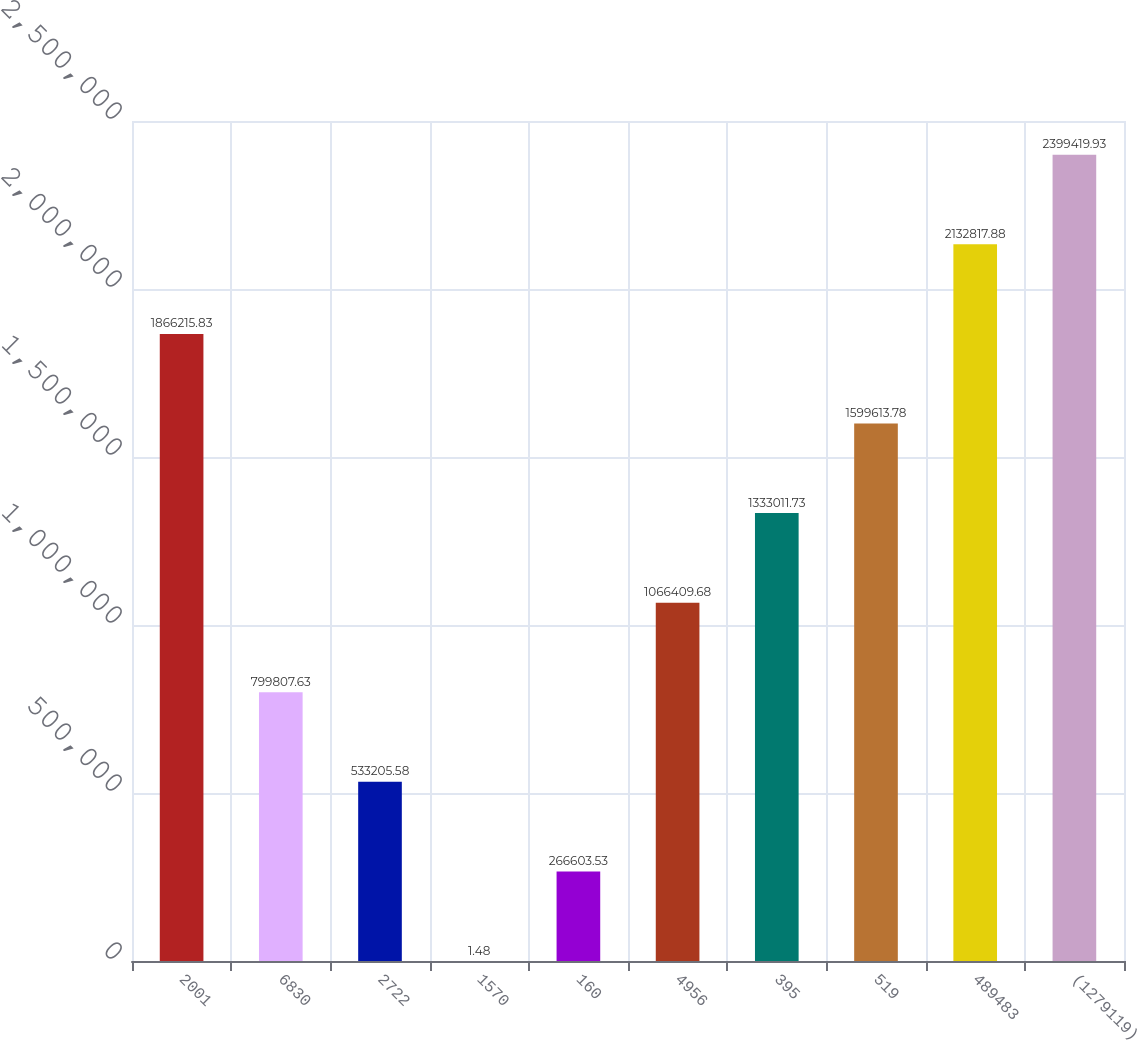<chart> <loc_0><loc_0><loc_500><loc_500><bar_chart><fcel>2001<fcel>6830<fcel>2722<fcel>1570<fcel>160<fcel>4956<fcel>395<fcel>519<fcel>489483<fcel>(1279119)<nl><fcel>1.86622e+06<fcel>799808<fcel>533206<fcel>1.48<fcel>266604<fcel>1.06641e+06<fcel>1.33301e+06<fcel>1.59961e+06<fcel>2.13282e+06<fcel>2.39942e+06<nl></chart> 